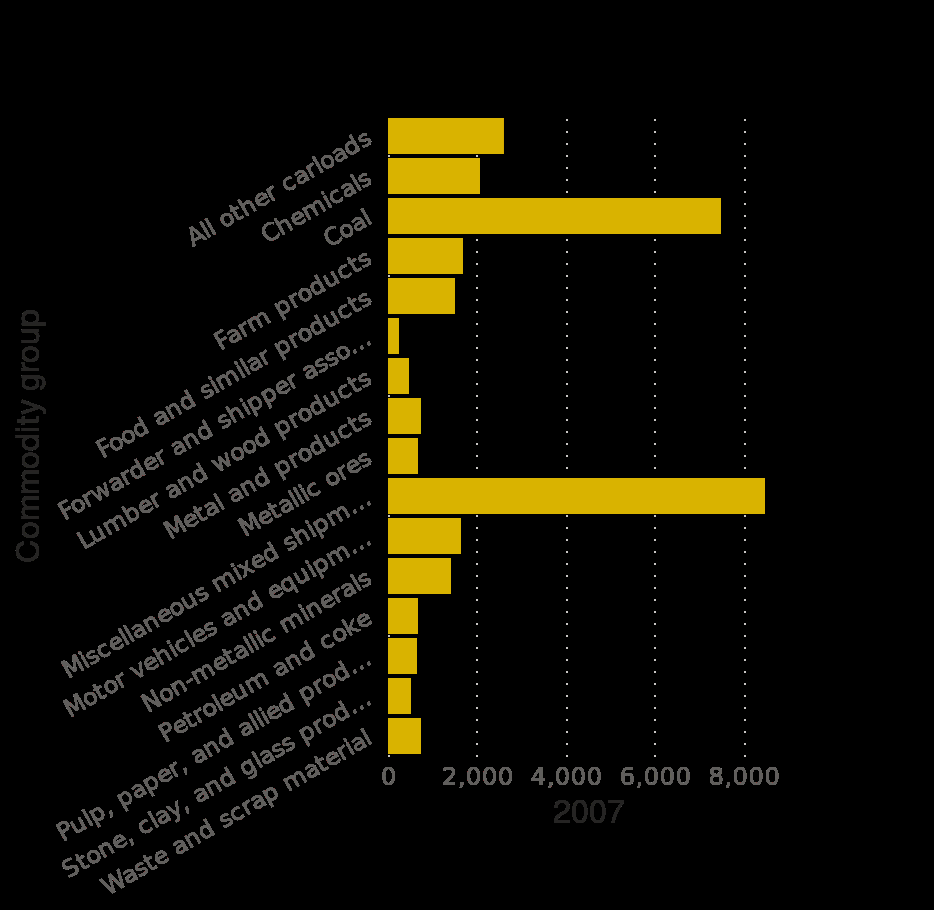<image>
please summary the statistics and relations of the chart MIscellaneous mixed shipments is the largest commodity transported by Class 1 Rail with over 8,000,000 carloads. The next highest is Coal with approximately 7,500,000 carloads. The commodity with the fewest carloads is Forwarder and Shipper Associates. What is the commodity with the fewest carloads transported by Class 1 Rail? Forwarder and Shipper Associates. What is represented on the y-axis of the graph? The y-axis of the graph represents the Commodity group. What is the scale used for the y-axis? The y-axis scale is categorical, ranging from "All other carloads" to a specific category (not mentioned in the description). 